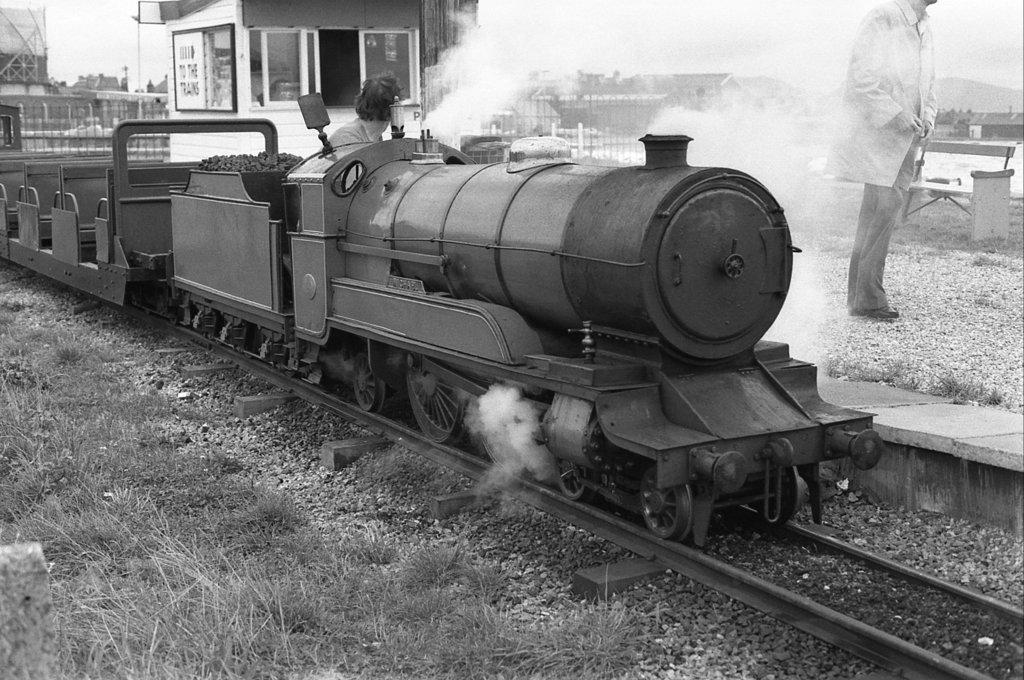Provide a one-sentence caption for the provided image. An old steam train pulls into station with a sign displaying an arrow and the text "To the trains" on it. 